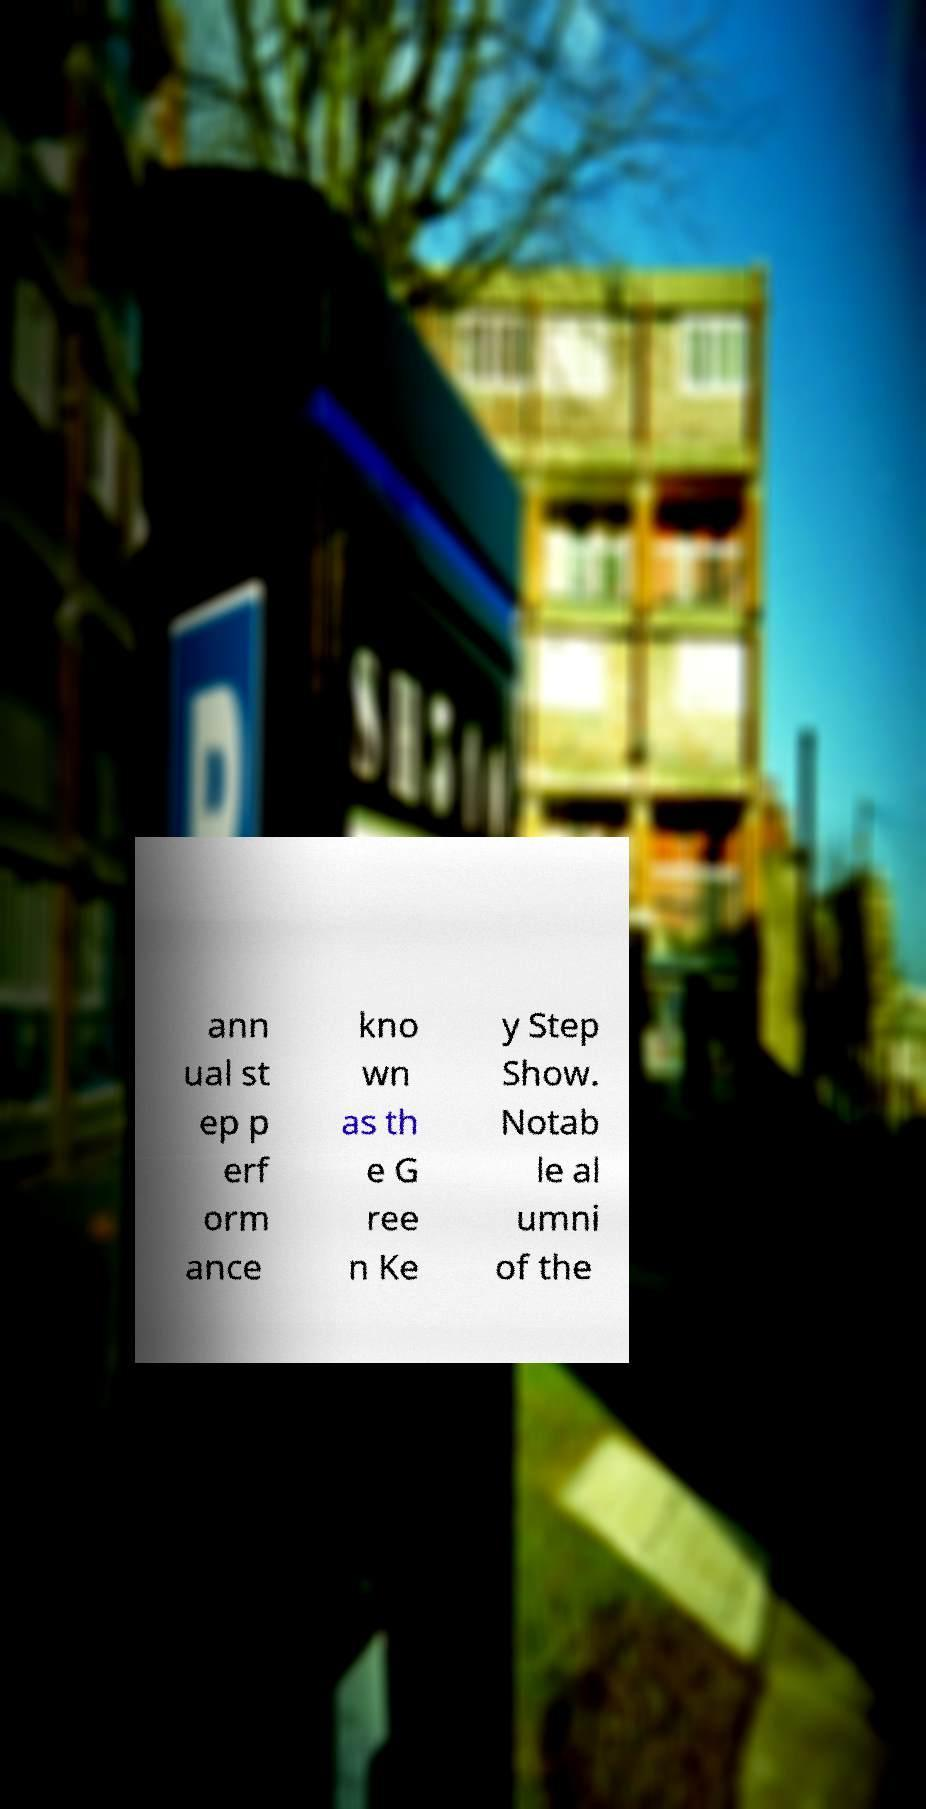Could you extract and type out the text from this image? ann ual st ep p erf orm ance kno wn as th e G ree n Ke y Step Show. Notab le al umni of the 